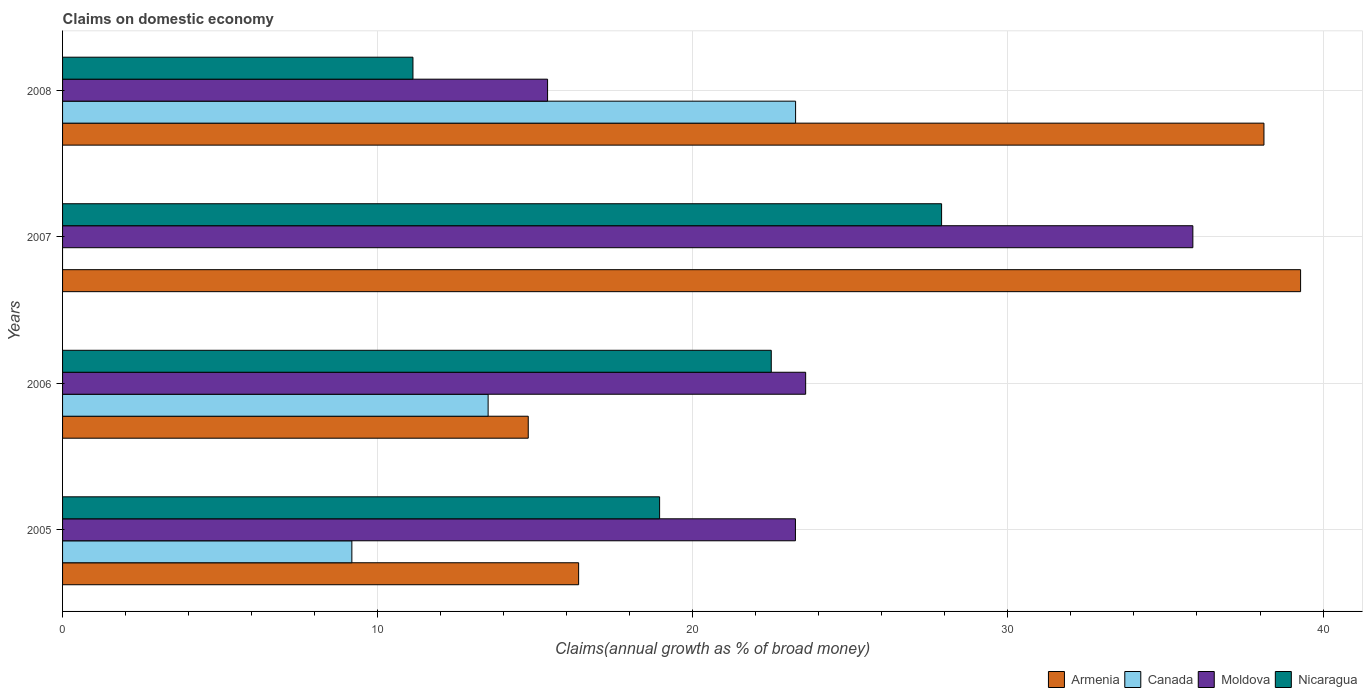Are the number of bars per tick equal to the number of legend labels?
Offer a very short reply. No. Are the number of bars on each tick of the Y-axis equal?
Your response must be concise. No. How many bars are there on the 1st tick from the top?
Offer a terse response. 4. What is the label of the 1st group of bars from the top?
Provide a succinct answer. 2008. In how many cases, is the number of bars for a given year not equal to the number of legend labels?
Your response must be concise. 1. What is the percentage of broad money claimed on domestic economy in Nicaragua in 2005?
Provide a short and direct response. 18.95. Across all years, what is the maximum percentage of broad money claimed on domestic economy in Nicaragua?
Provide a short and direct response. 27.9. Across all years, what is the minimum percentage of broad money claimed on domestic economy in Armenia?
Offer a very short reply. 14.78. In which year was the percentage of broad money claimed on domestic economy in Canada maximum?
Offer a very short reply. 2008. What is the total percentage of broad money claimed on domestic economy in Nicaragua in the graph?
Give a very brief answer. 80.45. What is the difference between the percentage of broad money claimed on domestic economy in Nicaragua in 2005 and that in 2008?
Give a very brief answer. 7.83. What is the difference between the percentage of broad money claimed on domestic economy in Nicaragua in 2006 and the percentage of broad money claimed on domestic economy in Armenia in 2005?
Provide a succinct answer. 6.11. What is the average percentage of broad money claimed on domestic economy in Moldova per year?
Offer a very short reply. 24.52. In the year 2006, what is the difference between the percentage of broad money claimed on domestic economy in Armenia and percentage of broad money claimed on domestic economy in Nicaragua?
Your response must be concise. -7.71. In how many years, is the percentage of broad money claimed on domestic economy in Canada greater than 18 %?
Provide a short and direct response. 1. What is the ratio of the percentage of broad money claimed on domestic economy in Armenia in 2006 to that in 2007?
Provide a short and direct response. 0.38. Is the percentage of broad money claimed on domestic economy in Moldova in 2005 less than that in 2008?
Give a very brief answer. No. What is the difference between the highest and the second highest percentage of broad money claimed on domestic economy in Nicaragua?
Give a very brief answer. 5.41. What is the difference between the highest and the lowest percentage of broad money claimed on domestic economy in Moldova?
Ensure brevity in your answer.  20.48. In how many years, is the percentage of broad money claimed on domestic economy in Moldova greater than the average percentage of broad money claimed on domestic economy in Moldova taken over all years?
Give a very brief answer. 1. Is the sum of the percentage of broad money claimed on domestic economy in Nicaragua in 2006 and 2007 greater than the maximum percentage of broad money claimed on domestic economy in Armenia across all years?
Make the answer very short. Yes. Is it the case that in every year, the sum of the percentage of broad money claimed on domestic economy in Nicaragua and percentage of broad money claimed on domestic economy in Armenia is greater than the sum of percentage of broad money claimed on domestic economy in Moldova and percentage of broad money claimed on domestic economy in Canada?
Give a very brief answer. Yes. Is it the case that in every year, the sum of the percentage of broad money claimed on domestic economy in Canada and percentage of broad money claimed on domestic economy in Moldova is greater than the percentage of broad money claimed on domestic economy in Nicaragua?
Give a very brief answer. Yes. How many bars are there?
Your answer should be compact. 15. What is the difference between two consecutive major ticks on the X-axis?
Make the answer very short. 10. Are the values on the major ticks of X-axis written in scientific E-notation?
Your answer should be very brief. No. Does the graph contain any zero values?
Your answer should be very brief. Yes. Does the graph contain grids?
Your answer should be very brief. Yes. Where does the legend appear in the graph?
Your answer should be very brief. Bottom right. How many legend labels are there?
Make the answer very short. 4. What is the title of the graph?
Your answer should be compact. Claims on domestic economy. What is the label or title of the X-axis?
Your response must be concise. Claims(annual growth as % of broad money). What is the Claims(annual growth as % of broad money) of Armenia in 2005?
Ensure brevity in your answer.  16.38. What is the Claims(annual growth as % of broad money) in Canada in 2005?
Your answer should be compact. 9.18. What is the Claims(annual growth as % of broad money) of Moldova in 2005?
Offer a very short reply. 23.26. What is the Claims(annual growth as % of broad money) in Nicaragua in 2005?
Keep it short and to the point. 18.95. What is the Claims(annual growth as % of broad money) in Armenia in 2006?
Give a very brief answer. 14.78. What is the Claims(annual growth as % of broad money) of Canada in 2006?
Provide a succinct answer. 13.5. What is the Claims(annual growth as % of broad money) in Moldova in 2006?
Ensure brevity in your answer.  23.58. What is the Claims(annual growth as % of broad money) in Nicaragua in 2006?
Make the answer very short. 22.49. What is the Claims(annual growth as % of broad money) of Armenia in 2007?
Give a very brief answer. 39.29. What is the Claims(annual growth as % of broad money) of Canada in 2007?
Offer a terse response. 0. What is the Claims(annual growth as % of broad money) in Moldova in 2007?
Make the answer very short. 35.87. What is the Claims(annual growth as % of broad money) in Nicaragua in 2007?
Your answer should be compact. 27.9. What is the Claims(annual growth as % of broad money) of Armenia in 2008?
Your response must be concise. 38.12. What is the Claims(annual growth as % of broad money) of Canada in 2008?
Keep it short and to the point. 23.26. What is the Claims(annual growth as % of broad money) of Moldova in 2008?
Keep it short and to the point. 15.39. What is the Claims(annual growth as % of broad money) of Nicaragua in 2008?
Provide a succinct answer. 11.12. Across all years, what is the maximum Claims(annual growth as % of broad money) of Armenia?
Provide a short and direct response. 39.29. Across all years, what is the maximum Claims(annual growth as % of broad money) in Canada?
Provide a succinct answer. 23.26. Across all years, what is the maximum Claims(annual growth as % of broad money) of Moldova?
Provide a succinct answer. 35.87. Across all years, what is the maximum Claims(annual growth as % of broad money) of Nicaragua?
Give a very brief answer. 27.9. Across all years, what is the minimum Claims(annual growth as % of broad money) of Armenia?
Provide a succinct answer. 14.78. Across all years, what is the minimum Claims(annual growth as % of broad money) of Moldova?
Provide a succinct answer. 15.39. Across all years, what is the minimum Claims(annual growth as % of broad money) of Nicaragua?
Make the answer very short. 11.12. What is the total Claims(annual growth as % of broad money) of Armenia in the graph?
Your answer should be compact. 108.57. What is the total Claims(annual growth as % of broad money) of Canada in the graph?
Ensure brevity in your answer.  45.95. What is the total Claims(annual growth as % of broad money) in Moldova in the graph?
Your response must be concise. 98.1. What is the total Claims(annual growth as % of broad money) in Nicaragua in the graph?
Provide a succinct answer. 80.45. What is the difference between the Claims(annual growth as % of broad money) in Armenia in 2005 and that in 2006?
Make the answer very short. 1.6. What is the difference between the Claims(annual growth as % of broad money) in Canada in 2005 and that in 2006?
Give a very brief answer. -4.32. What is the difference between the Claims(annual growth as % of broad money) in Moldova in 2005 and that in 2006?
Provide a succinct answer. -0.32. What is the difference between the Claims(annual growth as % of broad money) in Nicaragua in 2005 and that in 2006?
Offer a very short reply. -3.54. What is the difference between the Claims(annual growth as % of broad money) of Armenia in 2005 and that in 2007?
Ensure brevity in your answer.  -22.91. What is the difference between the Claims(annual growth as % of broad money) of Moldova in 2005 and that in 2007?
Your answer should be very brief. -12.61. What is the difference between the Claims(annual growth as % of broad money) in Nicaragua in 2005 and that in 2007?
Offer a very short reply. -8.95. What is the difference between the Claims(annual growth as % of broad money) in Armenia in 2005 and that in 2008?
Offer a very short reply. -21.75. What is the difference between the Claims(annual growth as % of broad money) of Canada in 2005 and that in 2008?
Your response must be concise. -14.08. What is the difference between the Claims(annual growth as % of broad money) of Moldova in 2005 and that in 2008?
Your answer should be very brief. 7.87. What is the difference between the Claims(annual growth as % of broad money) in Nicaragua in 2005 and that in 2008?
Ensure brevity in your answer.  7.83. What is the difference between the Claims(annual growth as % of broad money) of Armenia in 2006 and that in 2007?
Your answer should be compact. -24.51. What is the difference between the Claims(annual growth as % of broad money) in Moldova in 2006 and that in 2007?
Make the answer very short. -12.29. What is the difference between the Claims(annual growth as % of broad money) in Nicaragua in 2006 and that in 2007?
Your answer should be very brief. -5.41. What is the difference between the Claims(annual growth as % of broad money) of Armenia in 2006 and that in 2008?
Your response must be concise. -23.35. What is the difference between the Claims(annual growth as % of broad money) of Canada in 2006 and that in 2008?
Make the answer very short. -9.76. What is the difference between the Claims(annual growth as % of broad money) in Moldova in 2006 and that in 2008?
Give a very brief answer. 8.19. What is the difference between the Claims(annual growth as % of broad money) in Nicaragua in 2006 and that in 2008?
Your answer should be compact. 11.37. What is the difference between the Claims(annual growth as % of broad money) in Armenia in 2007 and that in 2008?
Give a very brief answer. 1.16. What is the difference between the Claims(annual growth as % of broad money) of Moldova in 2007 and that in 2008?
Keep it short and to the point. 20.48. What is the difference between the Claims(annual growth as % of broad money) in Nicaragua in 2007 and that in 2008?
Offer a terse response. 16.78. What is the difference between the Claims(annual growth as % of broad money) in Armenia in 2005 and the Claims(annual growth as % of broad money) in Canada in 2006?
Provide a succinct answer. 2.87. What is the difference between the Claims(annual growth as % of broad money) in Armenia in 2005 and the Claims(annual growth as % of broad money) in Moldova in 2006?
Make the answer very short. -7.2. What is the difference between the Claims(annual growth as % of broad money) of Armenia in 2005 and the Claims(annual growth as % of broad money) of Nicaragua in 2006?
Your response must be concise. -6.11. What is the difference between the Claims(annual growth as % of broad money) of Canada in 2005 and the Claims(annual growth as % of broad money) of Moldova in 2006?
Give a very brief answer. -14.4. What is the difference between the Claims(annual growth as % of broad money) in Canada in 2005 and the Claims(annual growth as % of broad money) in Nicaragua in 2006?
Provide a succinct answer. -13.31. What is the difference between the Claims(annual growth as % of broad money) in Moldova in 2005 and the Claims(annual growth as % of broad money) in Nicaragua in 2006?
Offer a terse response. 0.77. What is the difference between the Claims(annual growth as % of broad money) of Armenia in 2005 and the Claims(annual growth as % of broad money) of Moldova in 2007?
Offer a very short reply. -19.49. What is the difference between the Claims(annual growth as % of broad money) of Armenia in 2005 and the Claims(annual growth as % of broad money) of Nicaragua in 2007?
Your answer should be compact. -11.52. What is the difference between the Claims(annual growth as % of broad money) in Canada in 2005 and the Claims(annual growth as % of broad money) in Moldova in 2007?
Your answer should be very brief. -26.69. What is the difference between the Claims(annual growth as % of broad money) of Canada in 2005 and the Claims(annual growth as % of broad money) of Nicaragua in 2007?
Your answer should be compact. -18.71. What is the difference between the Claims(annual growth as % of broad money) in Moldova in 2005 and the Claims(annual growth as % of broad money) in Nicaragua in 2007?
Offer a terse response. -4.64. What is the difference between the Claims(annual growth as % of broad money) in Armenia in 2005 and the Claims(annual growth as % of broad money) in Canada in 2008?
Give a very brief answer. -6.88. What is the difference between the Claims(annual growth as % of broad money) in Armenia in 2005 and the Claims(annual growth as % of broad money) in Moldova in 2008?
Make the answer very short. 0.99. What is the difference between the Claims(annual growth as % of broad money) of Armenia in 2005 and the Claims(annual growth as % of broad money) of Nicaragua in 2008?
Provide a succinct answer. 5.26. What is the difference between the Claims(annual growth as % of broad money) of Canada in 2005 and the Claims(annual growth as % of broad money) of Moldova in 2008?
Give a very brief answer. -6.21. What is the difference between the Claims(annual growth as % of broad money) of Canada in 2005 and the Claims(annual growth as % of broad money) of Nicaragua in 2008?
Ensure brevity in your answer.  -1.94. What is the difference between the Claims(annual growth as % of broad money) of Moldova in 2005 and the Claims(annual growth as % of broad money) of Nicaragua in 2008?
Your answer should be compact. 12.14. What is the difference between the Claims(annual growth as % of broad money) in Armenia in 2006 and the Claims(annual growth as % of broad money) in Moldova in 2007?
Provide a succinct answer. -21.09. What is the difference between the Claims(annual growth as % of broad money) of Armenia in 2006 and the Claims(annual growth as % of broad money) of Nicaragua in 2007?
Your answer should be compact. -13.12. What is the difference between the Claims(annual growth as % of broad money) of Canada in 2006 and the Claims(annual growth as % of broad money) of Moldova in 2007?
Your response must be concise. -22.36. What is the difference between the Claims(annual growth as % of broad money) of Canada in 2006 and the Claims(annual growth as % of broad money) of Nicaragua in 2007?
Give a very brief answer. -14.39. What is the difference between the Claims(annual growth as % of broad money) in Moldova in 2006 and the Claims(annual growth as % of broad money) in Nicaragua in 2007?
Your response must be concise. -4.31. What is the difference between the Claims(annual growth as % of broad money) in Armenia in 2006 and the Claims(annual growth as % of broad money) in Canada in 2008?
Your response must be concise. -8.48. What is the difference between the Claims(annual growth as % of broad money) of Armenia in 2006 and the Claims(annual growth as % of broad money) of Moldova in 2008?
Make the answer very short. -0.61. What is the difference between the Claims(annual growth as % of broad money) in Armenia in 2006 and the Claims(annual growth as % of broad money) in Nicaragua in 2008?
Offer a terse response. 3.66. What is the difference between the Claims(annual growth as % of broad money) of Canada in 2006 and the Claims(annual growth as % of broad money) of Moldova in 2008?
Keep it short and to the point. -1.89. What is the difference between the Claims(annual growth as % of broad money) of Canada in 2006 and the Claims(annual growth as % of broad money) of Nicaragua in 2008?
Your answer should be compact. 2.39. What is the difference between the Claims(annual growth as % of broad money) of Moldova in 2006 and the Claims(annual growth as % of broad money) of Nicaragua in 2008?
Your response must be concise. 12.46. What is the difference between the Claims(annual growth as % of broad money) of Armenia in 2007 and the Claims(annual growth as % of broad money) of Canada in 2008?
Give a very brief answer. 16.03. What is the difference between the Claims(annual growth as % of broad money) of Armenia in 2007 and the Claims(annual growth as % of broad money) of Moldova in 2008?
Make the answer very short. 23.9. What is the difference between the Claims(annual growth as % of broad money) in Armenia in 2007 and the Claims(annual growth as % of broad money) in Nicaragua in 2008?
Make the answer very short. 28.17. What is the difference between the Claims(annual growth as % of broad money) of Moldova in 2007 and the Claims(annual growth as % of broad money) of Nicaragua in 2008?
Make the answer very short. 24.75. What is the average Claims(annual growth as % of broad money) in Armenia per year?
Your answer should be compact. 27.14. What is the average Claims(annual growth as % of broad money) of Canada per year?
Make the answer very short. 11.49. What is the average Claims(annual growth as % of broad money) in Moldova per year?
Provide a short and direct response. 24.52. What is the average Claims(annual growth as % of broad money) in Nicaragua per year?
Provide a short and direct response. 20.11. In the year 2005, what is the difference between the Claims(annual growth as % of broad money) of Armenia and Claims(annual growth as % of broad money) of Canada?
Your answer should be very brief. 7.2. In the year 2005, what is the difference between the Claims(annual growth as % of broad money) in Armenia and Claims(annual growth as % of broad money) in Moldova?
Provide a succinct answer. -6.88. In the year 2005, what is the difference between the Claims(annual growth as % of broad money) of Armenia and Claims(annual growth as % of broad money) of Nicaragua?
Give a very brief answer. -2.57. In the year 2005, what is the difference between the Claims(annual growth as % of broad money) in Canada and Claims(annual growth as % of broad money) in Moldova?
Your answer should be very brief. -14.08. In the year 2005, what is the difference between the Claims(annual growth as % of broad money) of Canada and Claims(annual growth as % of broad money) of Nicaragua?
Keep it short and to the point. -9.77. In the year 2005, what is the difference between the Claims(annual growth as % of broad money) of Moldova and Claims(annual growth as % of broad money) of Nicaragua?
Your answer should be very brief. 4.31. In the year 2006, what is the difference between the Claims(annual growth as % of broad money) of Armenia and Claims(annual growth as % of broad money) of Canada?
Provide a succinct answer. 1.27. In the year 2006, what is the difference between the Claims(annual growth as % of broad money) of Armenia and Claims(annual growth as % of broad money) of Moldova?
Give a very brief answer. -8.8. In the year 2006, what is the difference between the Claims(annual growth as % of broad money) of Armenia and Claims(annual growth as % of broad money) of Nicaragua?
Give a very brief answer. -7.71. In the year 2006, what is the difference between the Claims(annual growth as % of broad money) in Canada and Claims(annual growth as % of broad money) in Moldova?
Ensure brevity in your answer.  -10.08. In the year 2006, what is the difference between the Claims(annual growth as % of broad money) in Canada and Claims(annual growth as % of broad money) in Nicaragua?
Provide a succinct answer. -8.99. In the year 2006, what is the difference between the Claims(annual growth as % of broad money) of Moldova and Claims(annual growth as % of broad money) of Nicaragua?
Provide a succinct answer. 1.09. In the year 2007, what is the difference between the Claims(annual growth as % of broad money) of Armenia and Claims(annual growth as % of broad money) of Moldova?
Your answer should be very brief. 3.42. In the year 2007, what is the difference between the Claims(annual growth as % of broad money) of Armenia and Claims(annual growth as % of broad money) of Nicaragua?
Ensure brevity in your answer.  11.39. In the year 2007, what is the difference between the Claims(annual growth as % of broad money) of Moldova and Claims(annual growth as % of broad money) of Nicaragua?
Provide a succinct answer. 7.97. In the year 2008, what is the difference between the Claims(annual growth as % of broad money) of Armenia and Claims(annual growth as % of broad money) of Canada?
Provide a succinct answer. 14.86. In the year 2008, what is the difference between the Claims(annual growth as % of broad money) in Armenia and Claims(annual growth as % of broad money) in Moldova?
Your answer should be very brief. 22.73. In the year 2008, what is the difference between the Claims(annual growth as % of broad money) of Armenia and Claims(annual growth as % of broad money) of Nicaragua?
Offer a terse response. 27.01. In the year 2008, what is the difference between the Claims(annual growth as % of broad money) in Canada and Claims(annual growth as % of broad money) in Moldova?
Ensure brevity in your answer.  7.87. In the year 2008, what is the difference between the Claims(annual growth as % of broad money) in Canada and Claims(annual growth as % of broad money) in Nicaragua?
Your response must be concise. 12.14. In the year 2008, what is the difference between the Claims(annual growth as % of broad money) in Moldova and Claims(annual growth as % of broad money) in Nicaragua?
Make the answer very short. 4.27. What is the ratio of the Claims(annual growth as % of broad money) of Armenia in 2005 to that in 2006?
Provide a succinct answer. 1.11. What is the ratio of the Claims(annual growth as % of broad money) of Canada in 2005 to that in 2006?
Your response must be concise. 0.68. What is the ratio of the Claims(annual growth as % of broad money) of Moldova in 2005 to that in 2006?
Your response must be concise. 0.99. What is the ratio of the Claims(annual growth as % of broad money) of Nicaragua in 2005 to that in 2006?
Make the answer very short. 0.84. What is the ratio of the Claims(annual growth as % of broad money) in Armenia in 2005 to that in 2007?
Your answer should be very brief. 0.42. What is the ratio of the Claims(annual growth as % of broad money) in Moldova in 2005 to that in 2007?
Your answer should be very brief. 0.65. What is the ratio of the Claims(annual growth as % of broad money) of Nicaragua in 2005 to that in 2007?
Your answer should be compact. 0.68. What is the ratio of the Claims(annual growth as % of broad money) in Armenia in 2005 to that in 2008?
Give a very brief answer. 0.43. What is the ratio of the Claims(annual growth as % of broad money) of Canada in 2005 to that in 2008?
Offer a terse response. 0.39. What is the ratio of the Claims(annual growth as % of broad money) in Moldova in 2005 to that in 2008?
Keep it short and to the point. 1.51. What is the ratio of the Claims(annual growth as % of broad money) of Nicaragua in 2005 to that in 2008?
Keep it short and to the point. 1.7. What is the ratio of the Claims(annual growth as % of broad money) in Armenia in 2006 to that in 2007?
Keep it short and to the point. 0.38. What is the ratio of the Claims(annual growth as % of broad money) in Moldova in 2006 to that in 2007?
Offer a terse response. 0.66. What is the ratio of the Claims(annual growth as % of broad money) in Nicaragua in 2006 to that in 2007?
Offer a terse response. 0.81. What is the ratio of the Claims(annual growth as % of broad money) of Armenia in 2006 to that in 2008?
Make the answer very short. 0.39. What is the ratio of the Claims(annual growth as % of broad money) in Canada in 2006 to that in 2008?
Your answer should be very brief. 0.58. What is the ratio of the Claims(annual growth as % of broad money) of Moldova in 2006 to that in 2008?
Your response must be concise. 1.53. What is the ratio of the Claims(annual growth as % of broad money) in Nicaragua in 2006 to that in 2008?
Offer a very short reply. 2.02. What is the ratio of the Claims(annual growth as % of broad money) of Armenia in 2007 to that in 2008?
Ensure brevity in your answer.  1.03. What is the ratio of the Claims(annual growth as % of broad money) of Moldova in 2007 to that in 2008?
Your response must be concise. 2.33. What is the ratio of the Claims(annual growth as % of broad money) in Nicaragua in 2007 to that in 2008?
Ensure brevity in your answer.  2.51. What is the difference between the highest and the second highest Claims(annual growth as % of broad money) of Armenia?
Offer a terse response. 1.16. What is the difference between the highest and the second highest Claims(annual growth as % of broad money) of Canada?
Your answer should be very brief. 9.76. What is the difference between the highest and the second highest Claims(annual growth as % of broad money) in Moldova?
Offer a very short reply. 12.29. What is the difference between the highest and the second highest Claims(annual growth as % of broad money) of Nicaragua?
Make the answer very short. 5.41. What is the difference between the highest and the lowest Claims(annual growth as % of broad money) of Armenia?
Make the answer very short. 24.51. What is the difference between the highest and the lowest Claims(annual growth as % of broad money) of Canada?
Your response must be concise. 23.26. What is the difference between the highest and the lowest Claims(annual growth as % of broad money) of Moldova?
Provide a succinct answer. 20.48. What is the difference between the highest and the lowest Claims(annual growth as % of broad money) of Nicaragua?
Your answer should be compact. 16.78. 